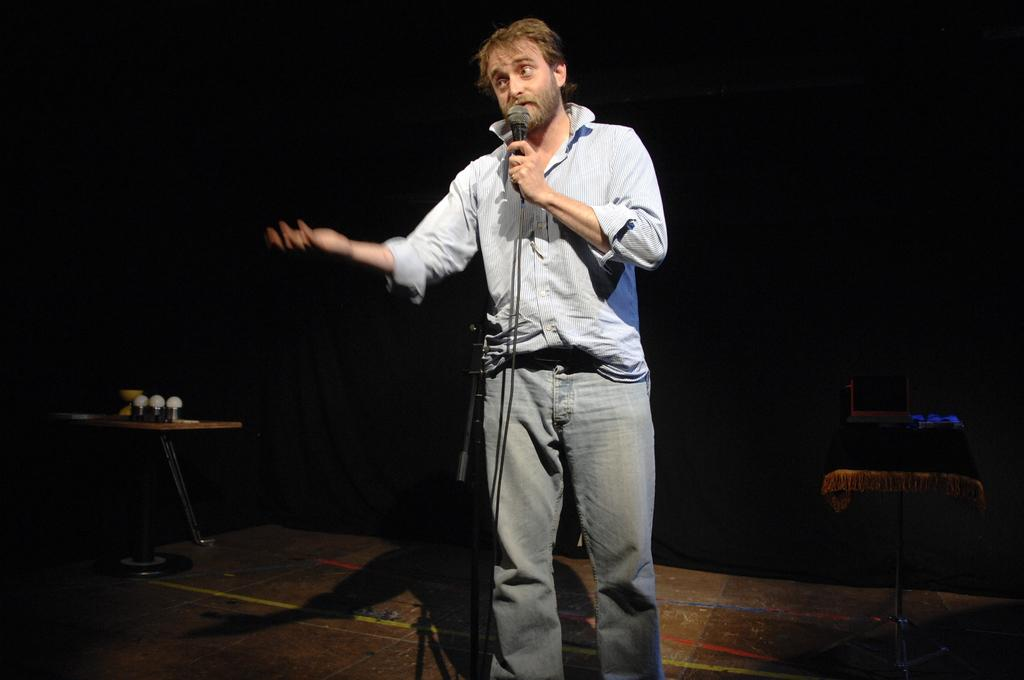What is the overall color scheme of the image? The background of the image is dark. What piece of furniture is present in the image? There is a table in the image. Who is in the image? There is a man standing in the image. What is the man holding in his hand? The man is holding a microphone in his hand. What electronic device is on the table in the background? There is a laptop on the table in the background. What type of noise can be heard coming from the laptop in the image? There is no indication of any sound or noise in the image, as it only shows a man holding a microphone and a laptop on a table. 